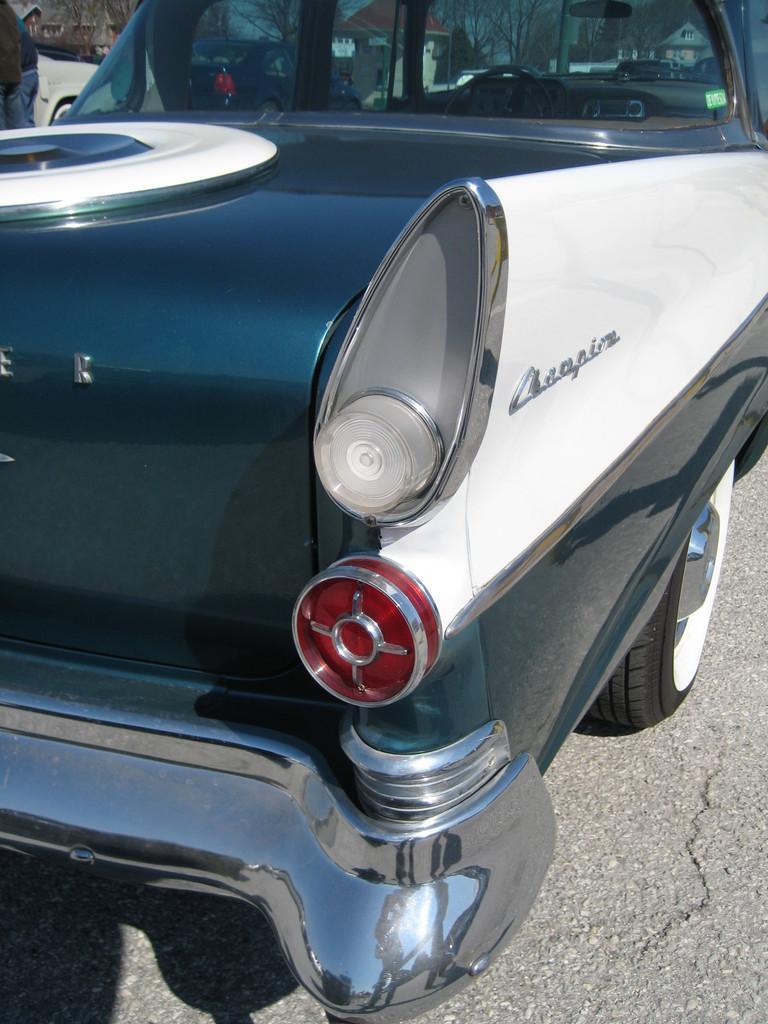Please provide a concise description of this image. In this image in the center there is a car with some text written on it which is white and black in colour. 